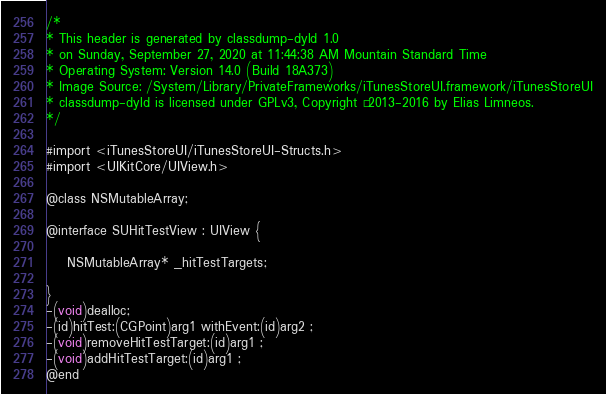<code> <loc_0><loc_0><loc_500><loc_500><_C_>/*
* This header is generated by classdump-dyld 1.0
* on Sunday, September 27, 2020 at 11:44:38 AM Mountain Standard Time
* Operating System: Version 14.0 (Build 18A373)
* Image Source: /System/Library/PrivateFrameworks/iTunesStoreUI.framework/iTunesStoreUI
* classdump-dyld is licensed under GPLv3, Copyright © 2013-2016 by Elias Limneos.
*/

#import <iTunesStoreUI/iTunesStoreUI-Structs.h>
#import <UIKitCore/UIView.h>

@class NSMutableArray;

@interface SUHitTestView : UIView {

	NSMutableArray* _hitTestTargets;

}
-(void)dealloc;
-(id)hitTest:(CGPoint)arg1 withEvent:(id)arg2 ;
-(void)removeHitTestTarget:(id)arg1 ;
-(void)addHitTestTarget:(id)arg1 ;
@end

</code> 